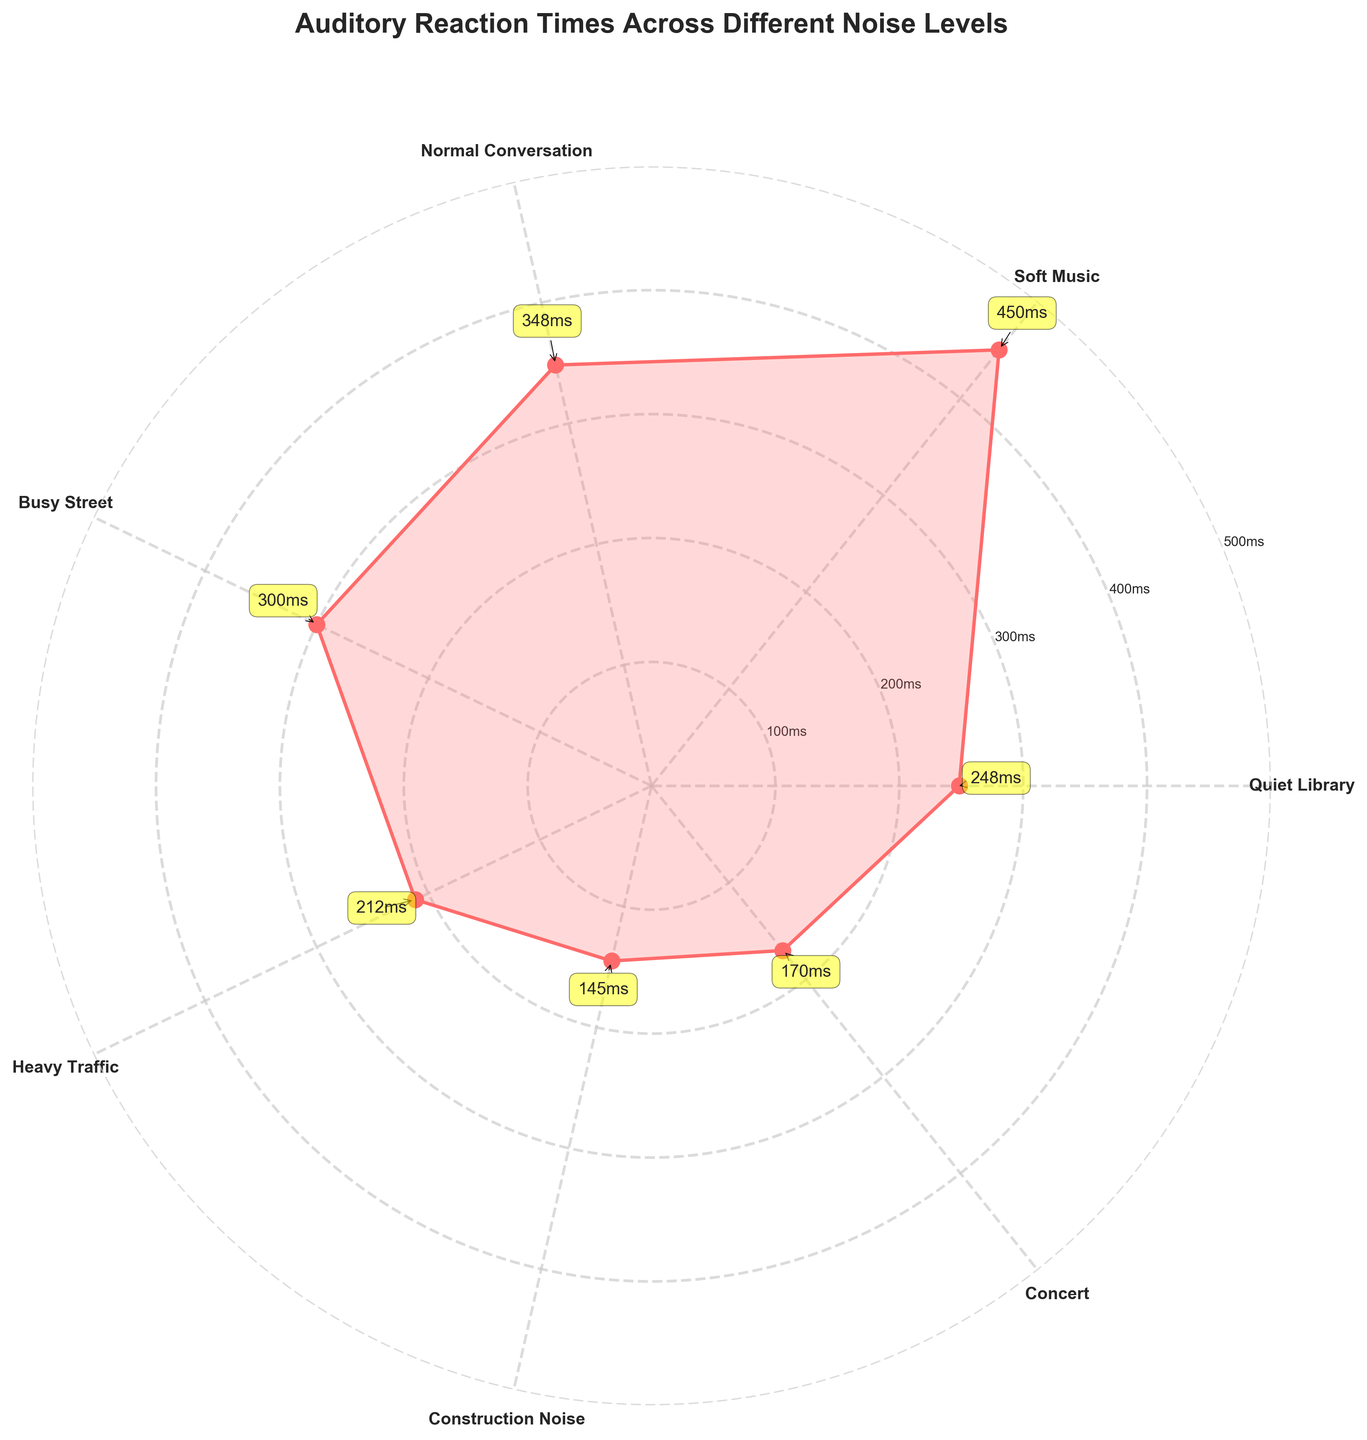What is the title of the rose chart? The title is usually positioned above the chart and is used to describe what the chart represents. In this case, the title is written clearly at the top of the figure.
Answer: Auditory Reaction Times Across Different Noise Levels How many categories of noise levels are plotted in the chart? To determine the number of categories, count the distinct labels on the perimeter of the rose chart. Each label corresponds to a specific noise level.
Answer: 7 What is the average reaction time in a Quiet Library? Locate the segment on the chart labeled "Quiet Library" and find the corresponding value indicated by the plotted line and any annotations.
Answer: 145ms Which noise level shows the highest average auditory reaction time? Observe the plotted data points and identify the one with the highest value. This value corresponds to the highest average reaction time.
Answer: Concert What’s the difference in auditory reaction time between Heavy Traffic and Normal Conversation? First, find the values for Heavy Traffic and Normal Conversation. Then, subtract the smaller value from the larger one to find the difference.
Answer: 95ms How do reaction times in Busy Street and Construction Noise compare? Locate the points for Busy Street and Construction Noise. Compare their values to determine which is higher or if they are equal.
Answer: Construction Noise is higher What is the range of reaction times presented in the chart? Determine the range by finding the difference between the maximum and minimum values plotted on the rose chart.
Answer: 310ms What is the pattern of reaction times as noise levels increase? Observe the trend of the data points from lower to higher noise levels and describe whether reaction times increase, decrease, or show no clear pattern.
Answer: Reaction times increase How does the reaction time for Soft Music compare to Busy Street? Find the values for both Soft Music and Busy Street. Compare these values to see which one is higher and by how much.
Answer: Busy Street is higher by 75ms What is the approximate average reaction time value for Normal Conversation? Locate the segment labeled "Normal Conversation" and find the value indicated by the plotted line and annotations.
Answer: 212ms 